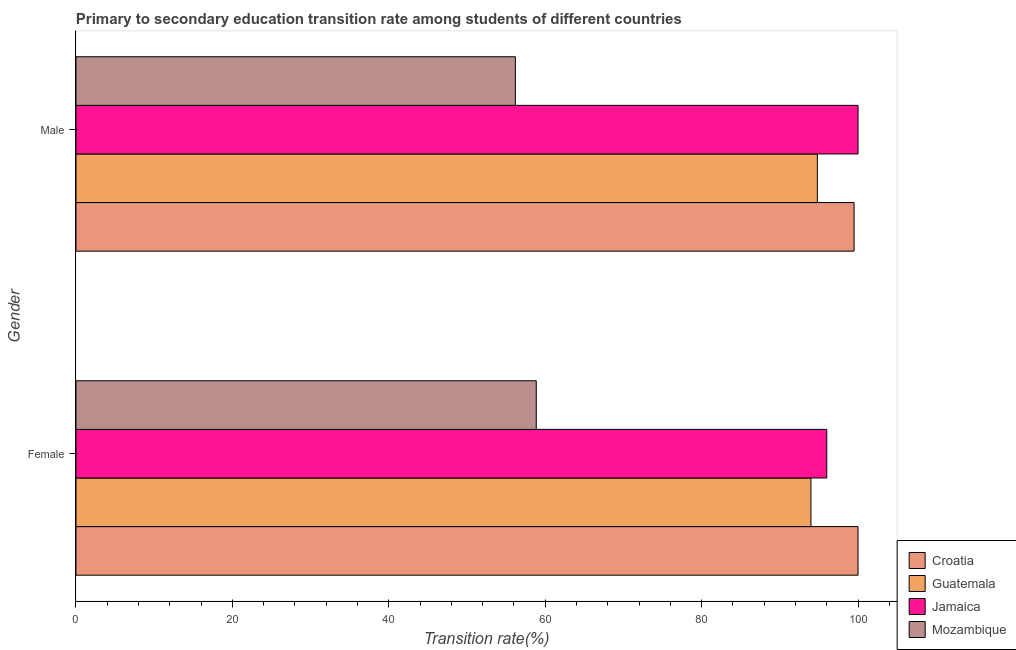What is the label of the 2nd group of bars from the top?
Offer a terse response. Female. What is the transition rate among male students in Mozambique?
Make the answer very short. 56.18. Across all countries, what is the minimum transition rate among male students?
Offer a very short reply. 56.18. In which country was the transition rate among male students maximum?
Offer a very short reply. Jamaica. In which country was the transition rate among female students minimum?
Your answer should be compact. Mozambique. What is the total transition rate among female students in the graph?
Offer a very short reply. 348.83. What is the difference between the transition rate among male students in Croatia and that in Mozambique?
Your response must be concise. 43.31. What is the difference between the transition rate among female students in Mozambique and the transition rate among male students in Croatia?
Give a very brief answer. -40.64. What is the average transition rate among male students per country?
Ensure brevity in your answer.  87.62. What is the difference between the transition rate among female students and transition rate among male students in Mozambique?
Your response must be concise. 2.67. What is the ratio of the transition rate among female students in Guatemala to that in Croatia?
Provide a short and direct response. 0.94. Is the transition rate among female students in Croatia less than that in Guatemala?
Keep it short and to the point. No. In how many countries, is the transition rate among male students greater than the average transition rate among male students taken over all countries?
Keep it short and to the point. 3. What does the 3rd bar from the top in Female represents?
Your answer should be very brief. Guatemala. What does the 4th bar from the bottom in Female represents?
Ensure brevity in your answer.  Mozambique. How many bars are there?
Make the answer very short. 8. How many countries are there in the graph?
Your answer should be very brief. 4. Are the values on the major ticks of X-axis written in scientific E-notation?
Keep it short and to the point. No. Does the graph contain any zero values?
Your answer should be compact. No. Where does the legend appear in the graph?
Keep it short and to the point. Bottom right. How many legend labels are there?
Your answer should be compact. 4. How are the legend labels stacked?
Your response must be concise. Vertical. What is the title of the graph?
Provide a succinct answer. Primary to secondary education transition rate among students of different countries. What is the label or title of the X-axis?
Ensure brevity in your answer.  Transition rate(%). What is the Transition rate(%) in Croatia in Female?
Your answer should be compact. 100. What is the Transition rate(%) in Guatemala in Female?
Your answer should be very brief. 93.98. What is the Transition rate(%) in Jamaica in Female?
Ensure brevity in your answer.  96. What is the Transition rate(%) of Mozambique in Female?
Offer a very short reply. 58.85. What is the Transition rate(%) of Croatia in Male?
Your answer should be very brief. 99.49. What is the Transition rate(%) in Guatemala in Male?
Give a very brief answer. 94.8. What is the Transition rate(%) of Jamaica in Male?
Make the answer very short. 100. What is the Transition rate(%) in Mozambique in Male?
Your response must be concise. 56.18. Across all Gender, what is the maximum Transition rate(%) in Croatia?
Your response must be concise. 100. Across all Gender, what is the maximum Transition rate(%) in Guatemala?
Offer a terse response. 94.8. Across all Gender, what is the maximum Transition rate(%) in Jamaica?
Ensure brevity in your answer.  100. Across all Gender, what is the maximum Transition rate(%) in Mozambique?
Offer a terse response. 58.85. Across all Gender, what is the minimum Transition rate(%) in Croatia?
Your answer should be compact. 99.49. Across all Gender, what is the minimum Transition rate(%) in Guatemala?
Your answer should be very brief. 93.98. Across all Gender, what is the minimum Transition rate(%) of Jamaica?
Ensure brevity in your answer.  96. Across all Gender, what is the minimum Transition rate(%) in Mozambique?
Ensure brevity in your answer.  56.18. What is the total Transition rate(%) of Croatia in the graph?
Offer a terse response. 199.49. What is the total Transition rate(%) of Guatemala in the graph?
Your response must be concise. 188.77. What is the total Transition rate(%) in Jamaica in the graph?
Keep it short and to the point. 196. What is the total Transition rate(%) in Mozambique in the graph?
Your response must be concise. 115.04. What is the difference between the Transition rate(%) in Croatia in Female and that in Male?
Make the answer very short. 0.51. What is the difference between the Transition rate(%) in Guatemala in Female and that in Male?
Keep it short and to the point. -0.82. What is the difference between the Transition rate(%) of Jamaica in Female and that in Male?
Ensure brevity in your answer.  -4. What is the difference between the Transition rate(%) in Mozambique in Female and that in Male?
Provide a short and direct response. 2.67. What is the difference between the Transition rate(%) in Croatia in Female and the Transition rate(%) in Guatemala in Male?
Offer a terse response. 5.2. What is the difference between the Transition rate(%) of Croatia in Female and the Transition rate(%) of Mozambique in Male?
Your answer should be compact. 43.82. What is the difference between the Transition rate(%) of Guatemala in Female and the Transition rate(%) of Jamaica in Male?
Give a very brief answer. -6.02. What is the difference between the Transition rate(%) of Guatemala in Female and the Transition rate(%) of Mozambique in Male?
Your answer should be compact. 37.79. What is the difference between the Transition rate(%) of Jamaica in Female and the Transition rate(%) of Mozambique in Male?
Make the answer very short. 39.81. What is the average Transition rate(%) in Croatia per Gender?
Your answer should be very brief. 99.75. What is the average Transition rate(%) in Guatemala per Gender?
Make the answer very short. 94.39. What is the average Transition rate(%) of Jamaica per Gender?
Give a very brief answer. 98. What is the average Transition rate(%) of Mozambique per Gender?
Your answer should be compact. 57.52. What is the difference between the Transition rate(%) of Croatia and Transition rate(%) of Guatemala in Female?
Provide a succinct answer. 6.02. What is the difference between the Transition rate(%) in Croatia and Transition rate(%) in Jamaica in Female?
Ensure brevity in your answer.  4. What is the difference between the Transition rate(%) of Croatia and Transition rate(%) of Mozambique in Female?
Give a very brief answer. 41.15. What is the difference between the Transition rate(%) of Guatemala and Transition rate(%) of Jamaica in Female?
Offer a terse response. -2.02. What is the difference between the Transition rate(%) of Guatemala and Transition rate(%) of Mozambique in Female?
Provide a short and direct response. 35.12. What is the difference between the Transition rate(%) in Jamaica and Transition rate(%) in Mozambique in Female?
Your response must be concise. 37.15. What is the difference between the Transition rate(%) of Croatia and Transition rate(%) of Guatemala in Male?
Ensure brevity in your answer.  4.69. What is the difference between the Transition rate(%) of Croatia and Transition rate(%) of Jamaica in Male?
Offer a terse response. -0.51. What is the difference between the Transition rate(%) in Croatia and Transition rate(%) in Mozambique in Male?
Your response must be concise. 43.31. What is the difference between the Transition rate(%) in Guatemala and Transition rate(%) in Jamaica in Male?
Your response must be concise. -5.2. What is the difference between the Transition rate(%) in Guatemala and Transition rate(%) in Mozambique in Male?
Your response must be concise. 38.61. What is the difference between the Transition rate(%) of Jamaica and Transition rate(%) of Mozambique in Male?
Ensure brevity in your answer.  43.82. What is the ratio of the Transition rate(%) in Mozambique in Female to that in Male?
Provide a succinct answer. 1.05. What is the difference between the highest and the second highest Transition rate(%) in Croatia?
Ensure brevity in your answer.  0.51. What is the difference between the highest and the second highest Transition rate(%) of Guatemala?
Provide a short and direct response. 0.82. What is the difference between the highest and the second highest Transition rate(%) of Jamaica?
Offer a terse response. 4. What is the difference between the highest and the second highest Transition rate(%) of Mozambique?
Provide a short and direct response. 2.67. What is the difference between the highest and the lowest Transition rate(%) in Croatia?
Ensure brevity in your answer.  0.51. What is the difference between the highest and the lowest Transition rate(%) of Guatemala?
Your answer should be very brief. 0.82. What is the difference between the highest and the lowest Transition rate(%) of Jamaica?
Keep it short and to the point. 4. What is the difference between the highest and the lowest Transition rate(%) of Mozambique?
Provide a succinct answer. 2.67. 